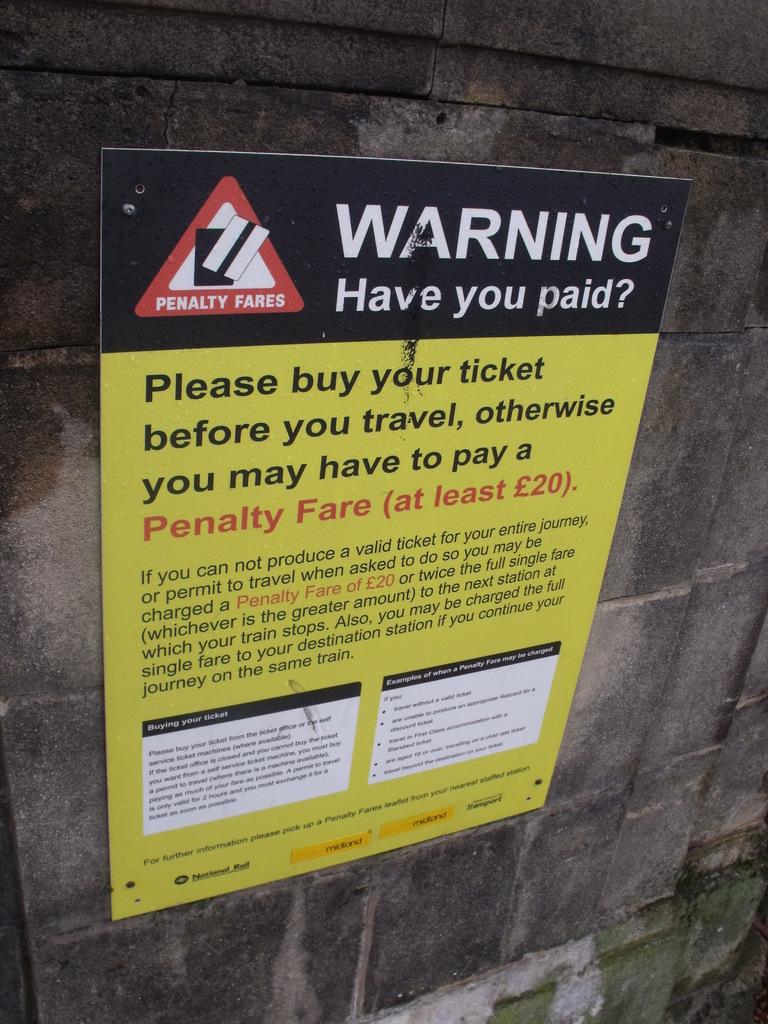What is the sign warning us on?
Ensure brevity in your answer.  Have you paid?. Is there a penalty for boarding without a ticket?
Your answer should be very brief. Yes. 